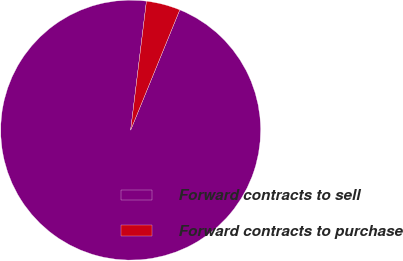Convert chart. <chart><loc_0><loc_0><loc_500><loc_500><pie_chart><fcel>Forward contracts to sell<fcel>Forward contracts to purchase<nl><fcel>95.77%<fcel>4.23%<nl></chart> 